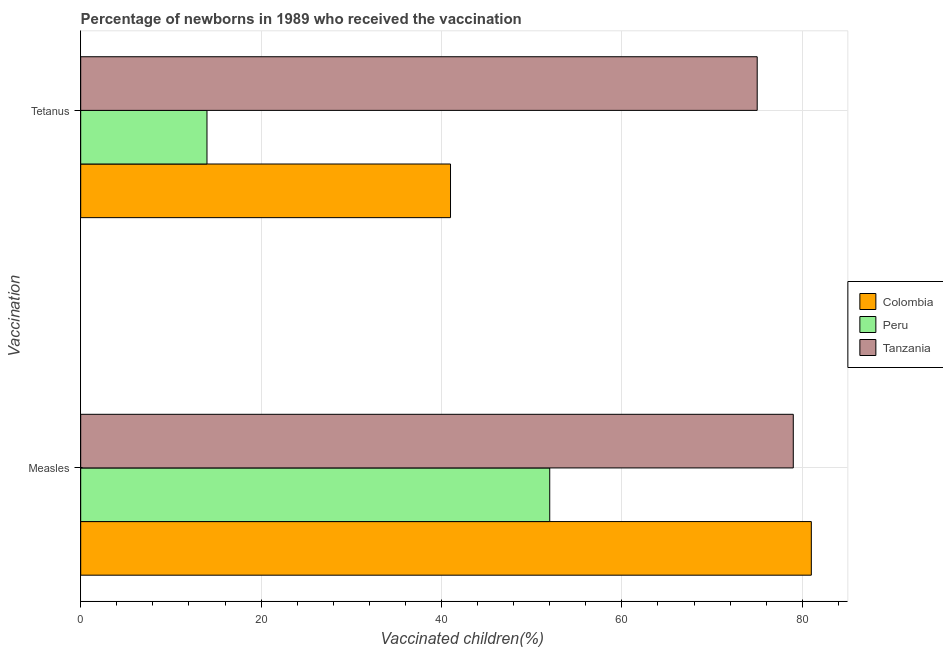Are the number of bars per tick equal to the number of legend labels?
Offer a terse response. Yes. Are the number of bars on each tick of the Y-axis equal?
Your answer should be compact. Yes. How many bars are there on the 2nd tick from the bottom?
Offer a terse response. 3. What is the label of the 2nd group of bars from the top?
Keep it short and to the point. Measles. What is the percentage of newborns who received vaccination for tetanus in Colombia?
Your answer should be very brief. 41. Across all countries, what is the maximum percentage of newborns who received vaccination for tetanus?
Your answer should be very brief. 75. Across all countries, what is the minimum percentage of newborns who received vaccination for tetanus?
Offer a terse response. 14. In which country was the percentage of newborns who received vaccination for tetanus maximum?
Keep it short and to the point. Tanzania. In which country was the percentage of newborns who received vaccination for measles minimum?
Your answer should be very brief. Peru. What is the total percentage of newborns who received vaccination for tetanus in the graph?
Offer a very short reply. 130. What is the difference between the percentage of newborns who received vaccination for measles in Peru and that in Colombia?
Your answer should be compact. -29. What is the average percentage of newborns who received vaccination for measles per country?
Offer a terse response. 70.67. What is the difference between the percentage of newborns who received vaccination for tetanus and percentage of newborns who received vaccination for measles in Colombia?
Your answer should be very brief. -40. In how many countries, is the percentage of newborns who received vaccination for measles greater than 60 %?
Offer a very short reply. 2. What is the ratio of the percentage of newborns who received vaccination for measles in Tanzania to that in Colombia?
Make the answer very short. 0.98. Is the percentage of newborns who received vaccination for measles in Colombia less than that in Tanzania?
Make the answer very short. No. In how many countries, is the percentage of newborns who received vaccination for tetanus greater than the average percentage of newborns who received vaccination for tetanus taken over all countries?
Provide a short and direct response. 1. What does the 3rd bar from the bottom in Tetanus represents?
Your answer should be very brief. Tanzania. How many bars are there?
Offer a very short reply. 6. What is the difference between two consecutive major ticks on the X-axis?
Offer a very short reply. 20. Does the graph contain any zero values?
Ensure brevity in your answer.  No. Does the graph contain grids?
Your answer should be very brief. Yes. How many legend labels are there?
Provide a short and direct response. 3. What is the title of the graph?
Keep it short and to the point. Percentage of newborns in 1989 who received the vaccination. What is the label or title of the X-axis?
Your response must be concise. Vaccinated children(%)
. What is the label or title of the Y-axis?
Provide a succinct answer. Vaccination. What is the Vaccinated children(%)
 of Tanzania in Measles?
Give a very brief answer. 79. What is the Vaccinated children(%)
 of Peru in Tetanus?
Your response must be concise. 14. What is the Vaccinated children(%)
 in Tanzania in Tetanus?
Make the answer very short. 75. Across all Vaccination, what is the maximum Vaccinated children(%)
 in Peru?
Offer a terse response. 52. Across all Vaccination, what is the maximum Vaccinated children(%)
 of Tanzania?
Offer a very short reply. 79. Across all Vaccination, what is the minimum Vaccinated children(%)
 of Peru?
Provide a short and direct response. 14. Across all Vaccination, what is the minimum Vaccinated children(%)
 of Tanzania?
Provide a succinct answer. 75. What is the total Vaccinated children(%)
 of Colombia in the graph?
Offer a terse response. 122. What is the total Vaccinated children(%)
 of Peru in the graph?
Your response must be concise. 66. What is the total Vaccinated children(%)
 of Tanzania in the graph?
Give a very brief answer. 154. What is the difference between the Vaccinated children(%)
 in Colombia in Measles and that in Tetanus?
Provide a short and direct response. 40. What is the difference between the Vaccinated children(%)
 of Peru in Measles and that in Tetanus?
Your answer should be very brief. 38. What is the difference between the Vaccinated children(%)
 of Tanzania in Measles and that in Tetanus?
Provide a short and direct response. 4. What is the difference between the Vaccinated children(%)
 in Colombia in Measles and the Vaccinated children(%)
 in Tanzania in Tetanus?
Your response must be concise. 6. What is the difference between the Vaccinated children(%)
 of Peru in Measles and the Vaccinated children(%)
 of Tanzania in Tetanus?
Your response must be concise. -23. What is the average Vaccinated children(%)
 of Colombia per Vaccination?
Make the answer very short. 61. What is the average Vaccinated children(%)
 in Tanzania per Vaccination?
Provide a succinct answer. 77. What is the difference between the Vaccinated children(%)
 in Colombia and Vaccinated children(%)
 in Peru in Measles?
Your answer should be very brief. 29. What is the difference between the Vaccinated children(%)
 of Colombia and Vaccinated children(%)
 of Tanzania in Measles?
Make the answer very short. 2. What is the difference between the Vaccinated children(%)
 in Colombia and Vaccinated children(%)
 in Peru in Tetanus?
Keep it short and to the point. 27. What is the difference between the Vaccinated children(%)
 in Colombia and Vaccinated children(%)
 in Tanzania in Tetanus?
Your answer should be very brief. -34. What is the difference between the Vaccinated children(%)
 of Peru and Vaccinated children(%)
 of Tanzania in Tetanus?
Offer a terse response. -61. What is the ratio of the Vaccinated children(%)
 of Colombia in Measles to that in Tetanus?
Offer a terse response. 1.98. What is the ratio of the Vaccinated children(%)
 in Peru in Measles to that in Tetanus?
Your response must be concise. 3.71. What is the ratio of the Vaccinated children(%)
 in Tanzania in Measles to that in Tetanus?
Your response must be concise. 1.05. What is the difference between the highest and the lowest Vaccinated children(%)
 in Tanzania?
Offer a terse response. 4. 